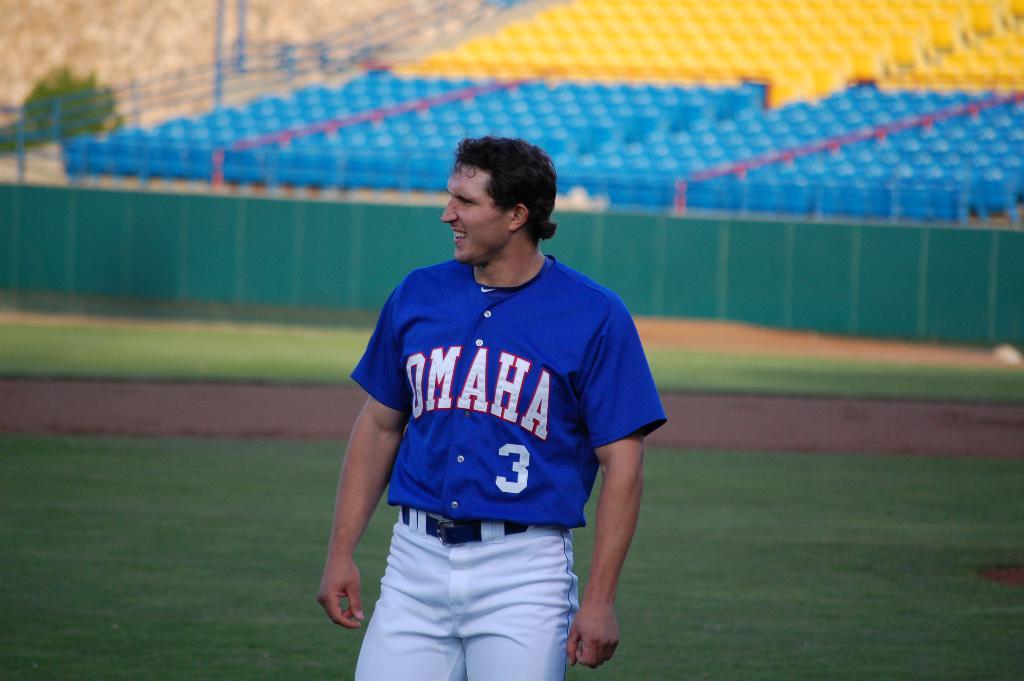What team does this player belong to?
Provide a short and direct response. Omaha. What is the mans jersey number?
Provide a short and direct response. 3. 